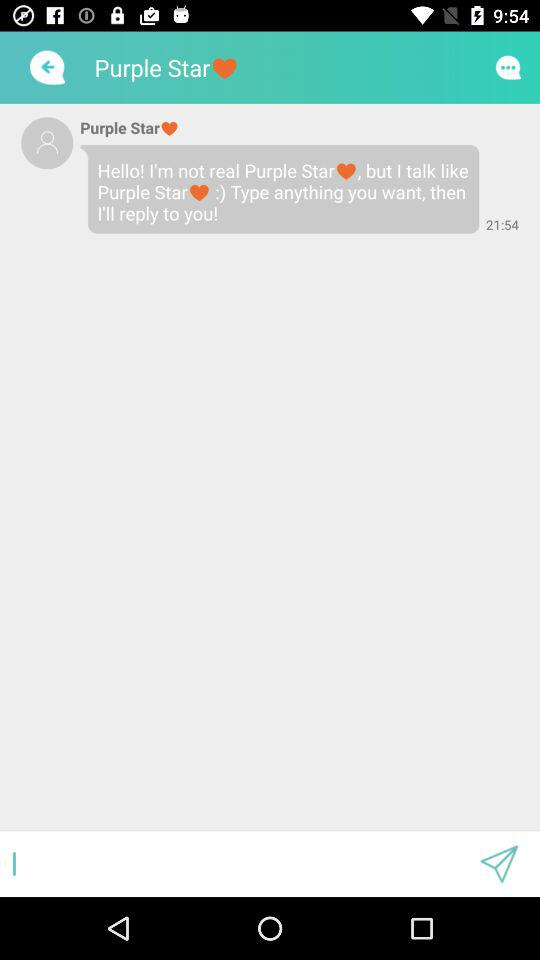On what day was the message sent?
When the provided information is insufficient, respond with <no answer>. <no answer> 